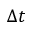Convert formula to latex. <formula><loc_0><loc_0><loc_500><loc_500>\Delta t</formula> 